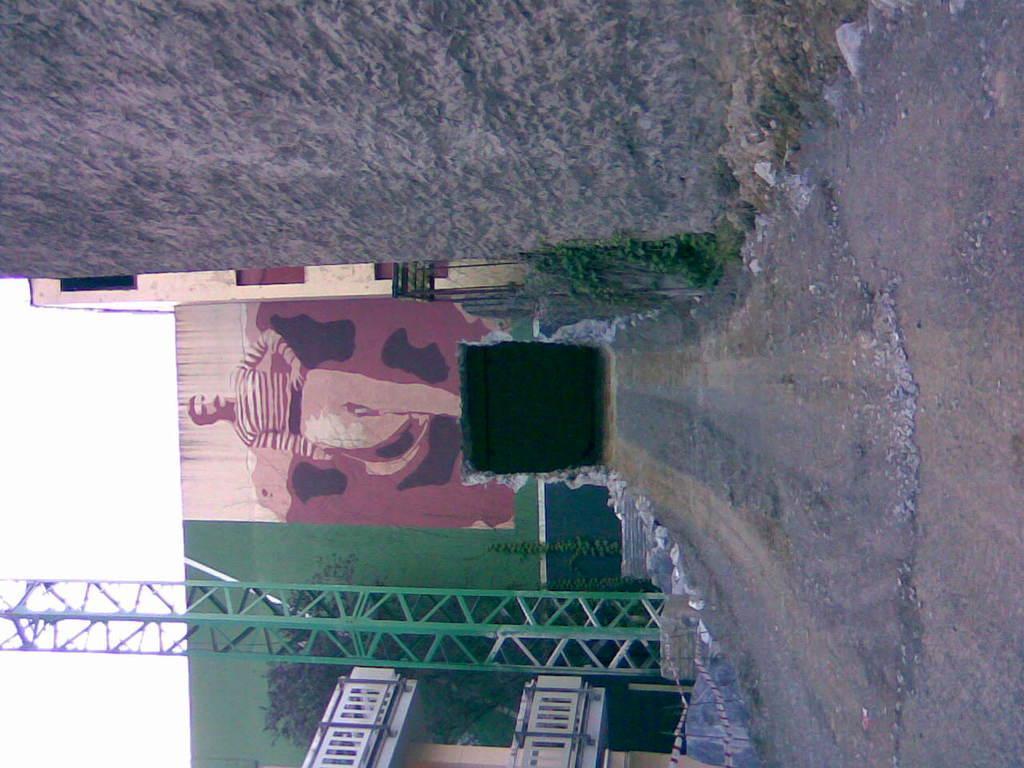Describe this image in one or two sentences. In this picture I can see the painting of a man on the wall. At the bottom there is a building, beside that I can see the pole. On the left there is a sky. 